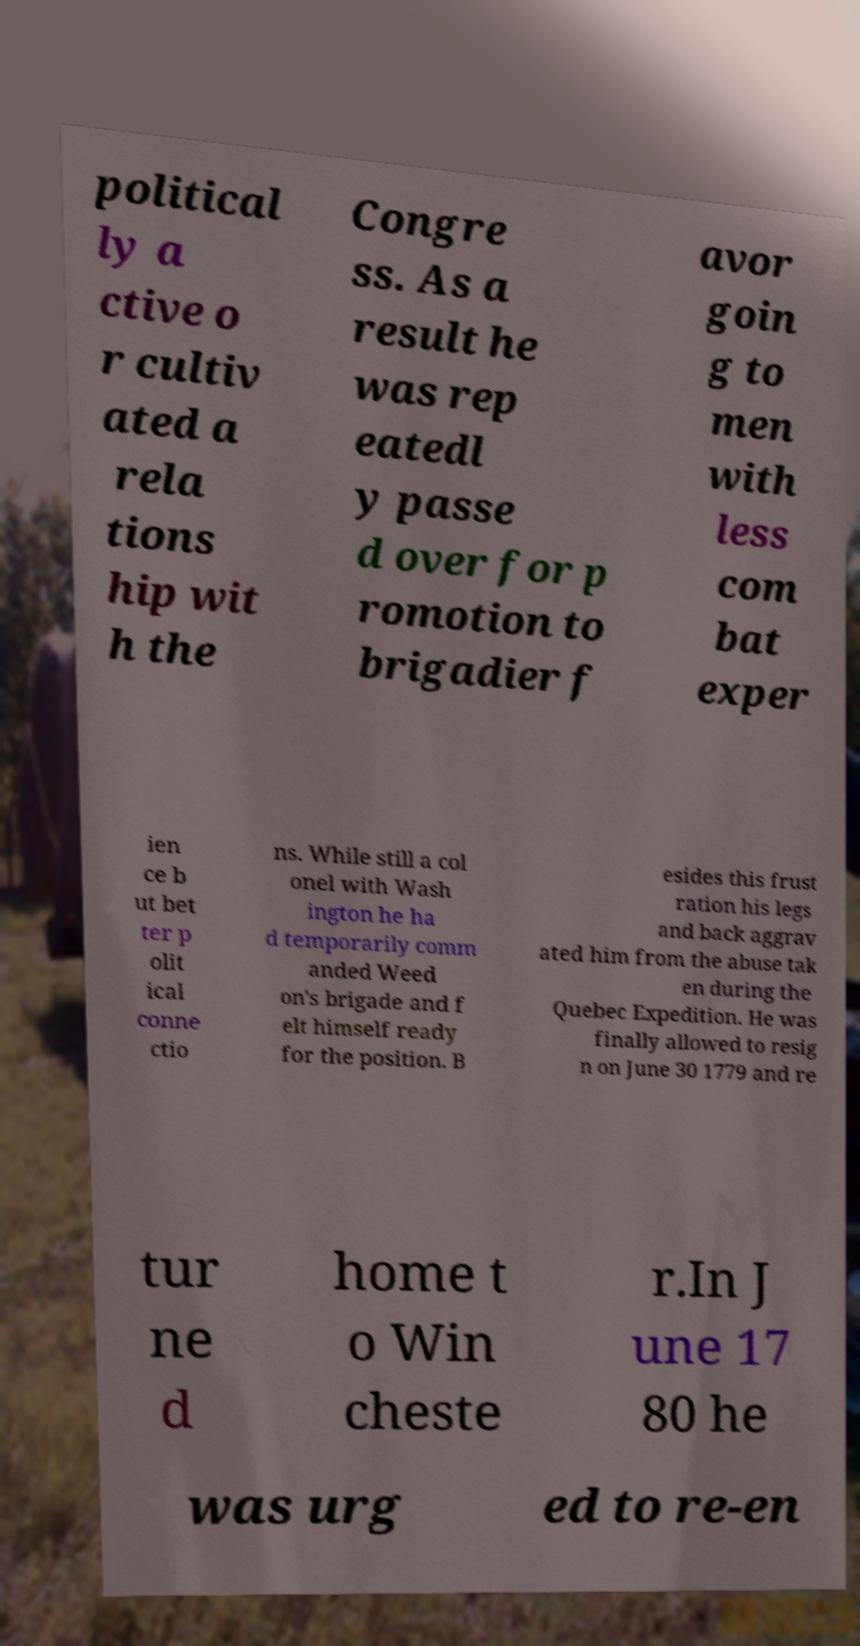Please identify and transcribe the text found in this image. political ly a ctive o r cultiv ated a rela tions hip wit h the Congre ss. As a result he was rep eatedl y passe d over for p romotion to brigadier f avor goin g to men with less com bat exper ien ce b ut bet ter p olit ical conne ctio ns. While still a col onel with Wash ington he ha d temporarily comm anded Weed on's brigade and f elt himself ready for the position. B esides this frust ration his legs and back aggrav ated him from the abuse tak en during the Quebec Expedition. He was finally allowed to resig n on June 30 1779 and re tur ne d home t o Win cheste r.In J une 17 80 he was urg ed to re-en 